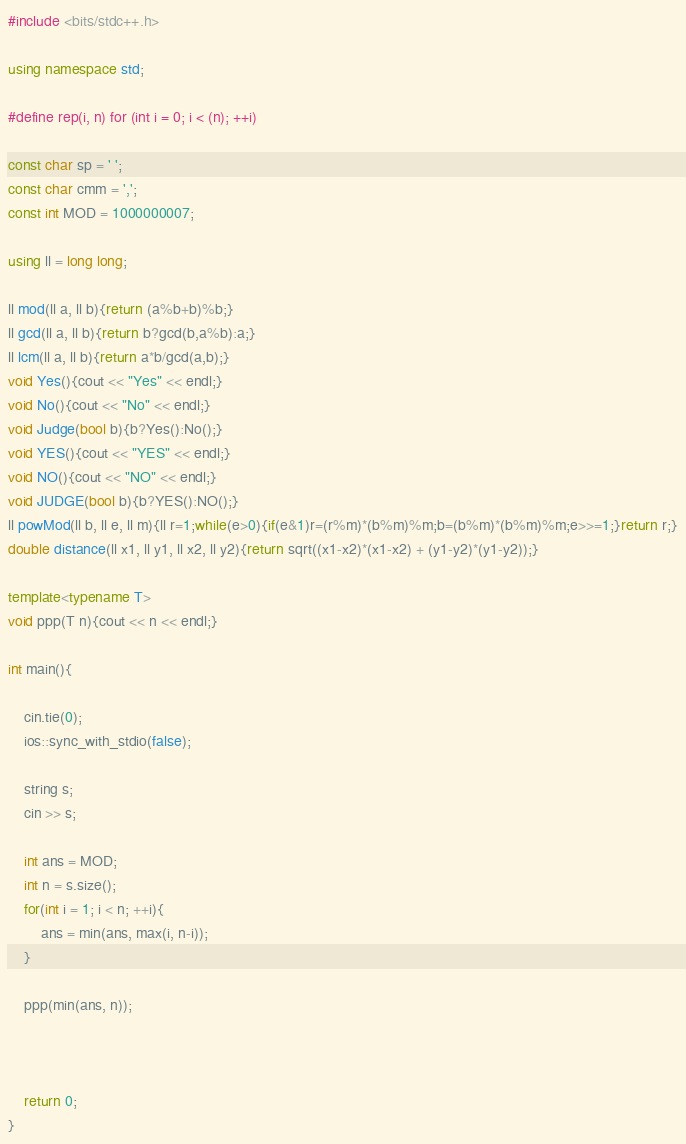<code> <loc_0><loc_0><loc_500><loc_500><_C++_>#include <bits/stdc++.h>

using namespace std;

#define rep(i, n) for (int i = 0; i < (n); ++i)

const char sp = ' ';
const char cmm = ',';
const int MOD = 1000000007;

using ll = long long;

ll mod(ll a, ll b){return (a%b+b)%b;}
ll gcd(ll a, ll b){return b?gcd(b,a%b):a;}
ll lcm(ll a, ll b){return a*b/gcd(a,b);}
void Yes(){cout << "Yes" << endl;}
void No(){cout << "No" << endl;}
void Judge(bool b){b?Yes():No();}
void YES(){cout << "YES" << endl;}
void NO(){cout << "NO" << endl;}
void JUDGE(bool b){b?YES():NO();}
ll powMod(ll b, ll e, ll m){ll r=1;while(e>0){if(e&1)r=(r%m)*(b%m)%m;b=(b%m)*(b%m)%m;e>>=1;}return r;}
double distance(ll x1, ll y1, ll x2, ll y2){return sqrt((x1-x2)*(x1-x2) + (y1-y2)*(y1-y2));}

template<typename T>
void ppp(T n){cout << n << endl;}

int main(){

    cin.tie(0);
    ios::sync_with_stdio(false);

    string s;
    cin >> s;

    int ans = MOD;
    int n = s.size();
    for(int i = 1; i < n; ++i){
        ans = min(ans, max(i, n-i));
    }

    ppp(min(ans, n));



    return 0;
}
</code> 